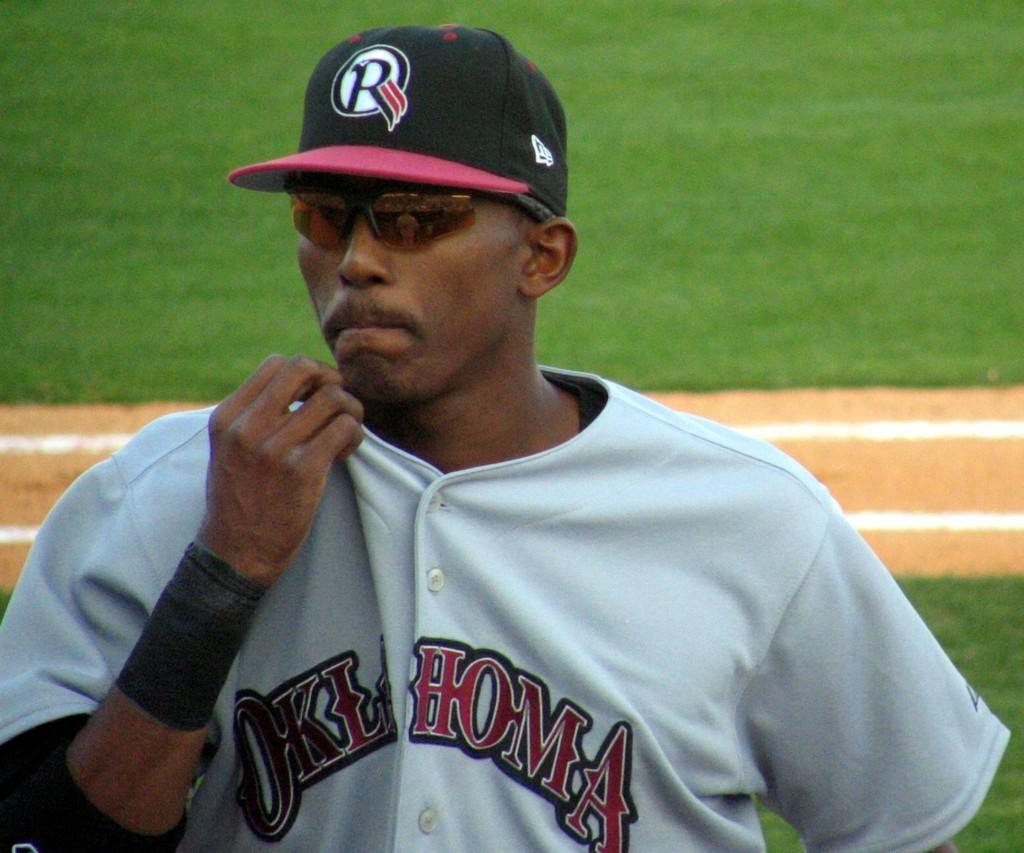<image>
Create a compact narrative representing the image presented. A player wears sunglasses and his Oklahoma uniform during a game. 